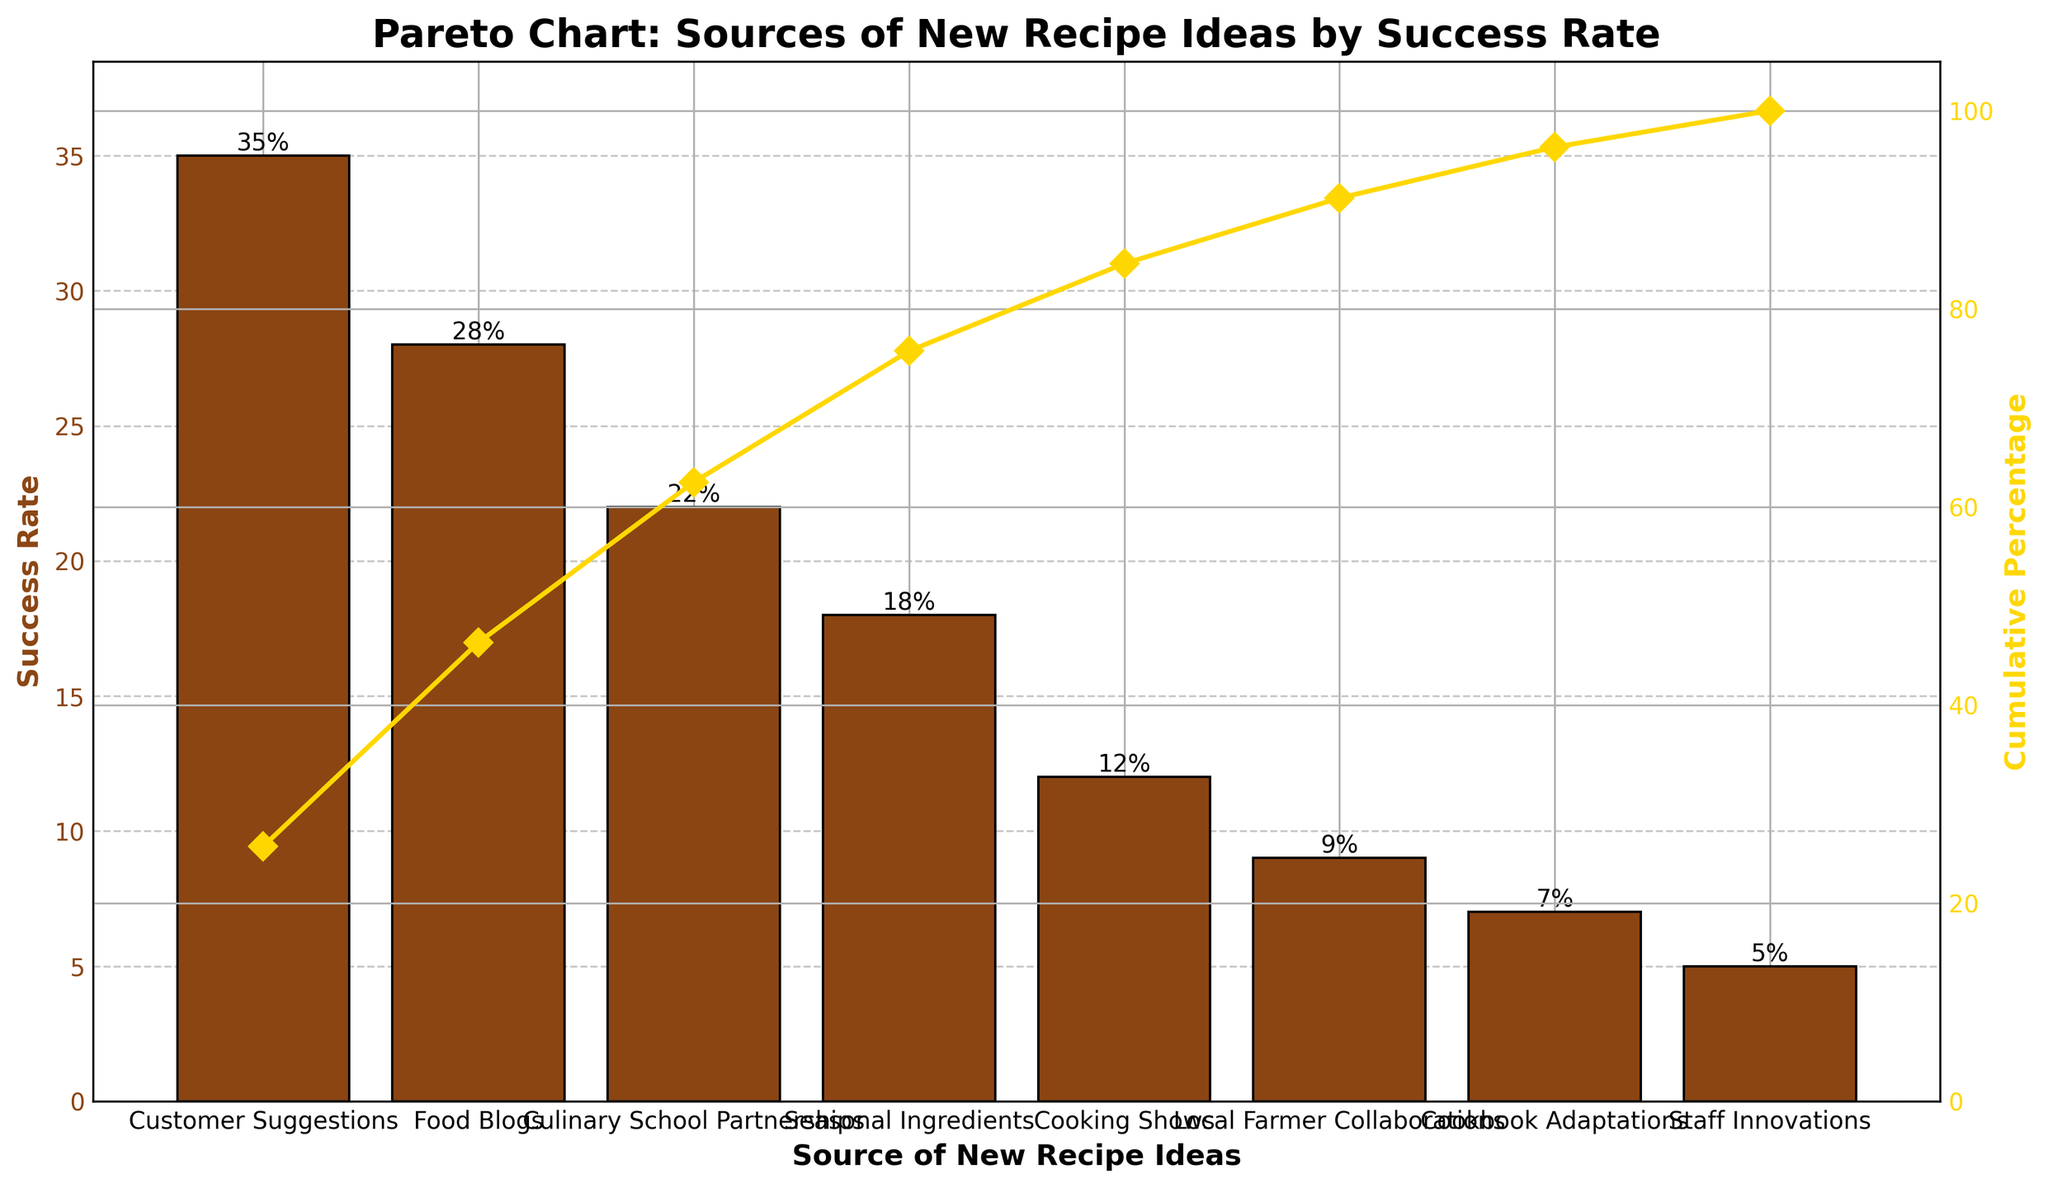What's the title of the chart? The title is located at the top of the chart, indicating what the chart is about.
Answer: Pareto Chart: Sources of New Recipe Ideas by Success Rate How many sources of new recipes are shown in the chart? Count the number of unique sources listed on the x-axis.
Answer: 8 Which source has the highest success rate? Look at the bar that reaches the highest point on the y-axis.
Answer: Customer Suggestions What is the success rate from Culinary School Partnerships? Find the bar labeled 'Culinary School Partnerships' and read its height on the y-axis.
Answer: 22% What percentage of the total success rate is cumulatively reached by Customer Suggestions and Food Blogs? Add the success rates of Customer Suggestions and Food Blogs, then calculate their cumulative percentage based on the total success rate. (35+28) / (35+28+22+18+12+9+7+5) * 100 = 63 / 136 * 100
Answer: 46.32% Which sources cumulatively account for over 75% of the success rate? Look at the cumulative percentage line on the secondary y-axis and identify sources up to where the cumulative percentage crosses 75%.
Answer: Customer Suggestions, Food Blogs, Culinary School Partnerships, Seasonal Ingredients What is the difference in success rate between Cooking Shows and Local Farmer Collaborations? Subtract the success rate of Local Farmer Collaborations from Cooking Shows.
Answer: 3% What is the cumulative percentage after adding Local Farmer Collaborations to the sources ranked before it? Look at the cumulative percentage value where Local Farmer Collaborations is added.
Answer: 95% How does the success rate of Staff Innovations compare to Cookbook Adaptations? Compare the heights of the bars labeled 'Staff Innovations' and 'Cookbook Adaptations'.
Answer: Staff Innovations have a lower success rate 